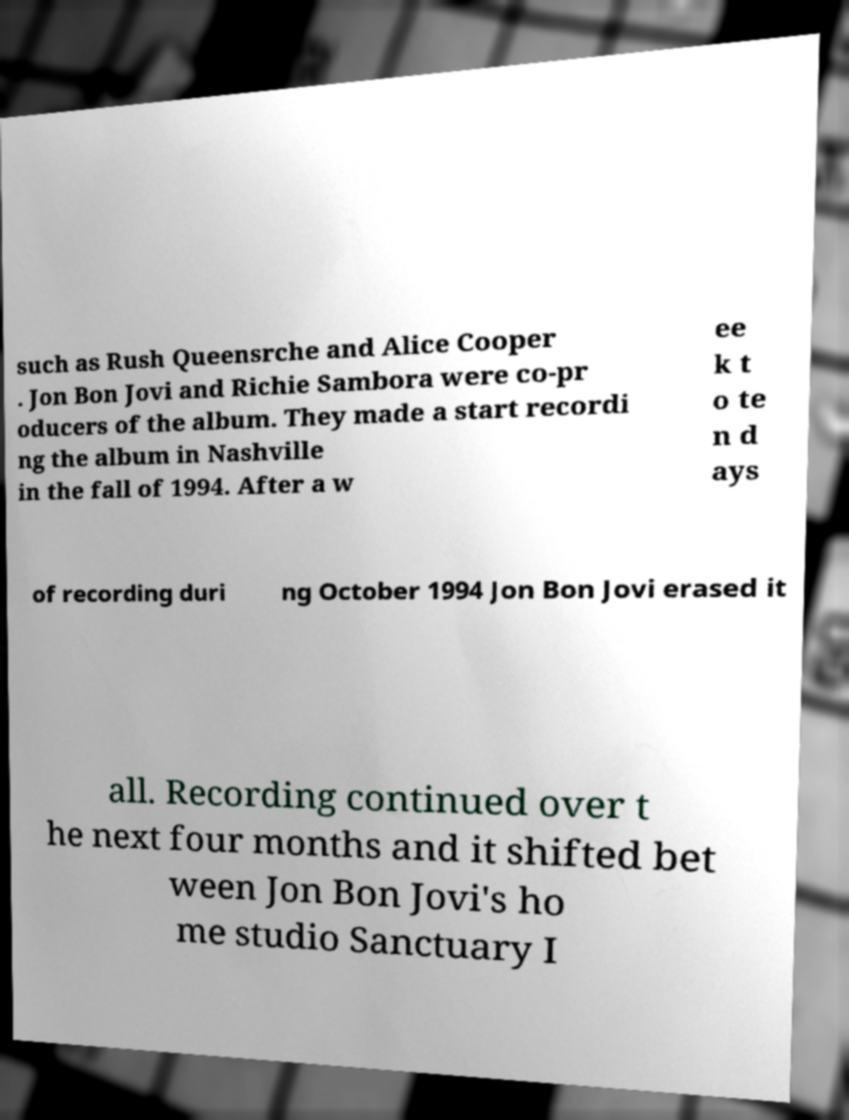Please identify and transcribe the text found in this image. such as Rush Queensrche and Alice Cooper . Jon Bon Jovi and Richie Sambora were co-pr oducers of the album. They made a start recordi ng the album in Nashville in the fall of 1994. After a w ee k t o te n d ays of recording duri ng October 1994 Jon Bon Jovi erased it all. Recording continued over t he next four months and it shifted bet ween Jon Bon Jovi's ho me studio Sanctuary I 